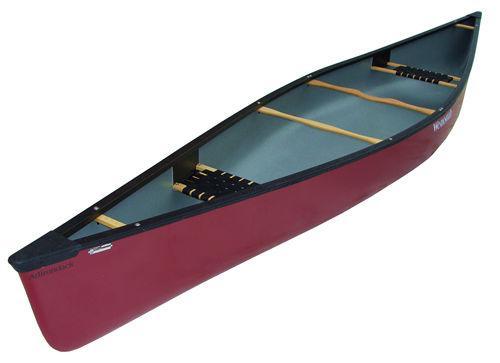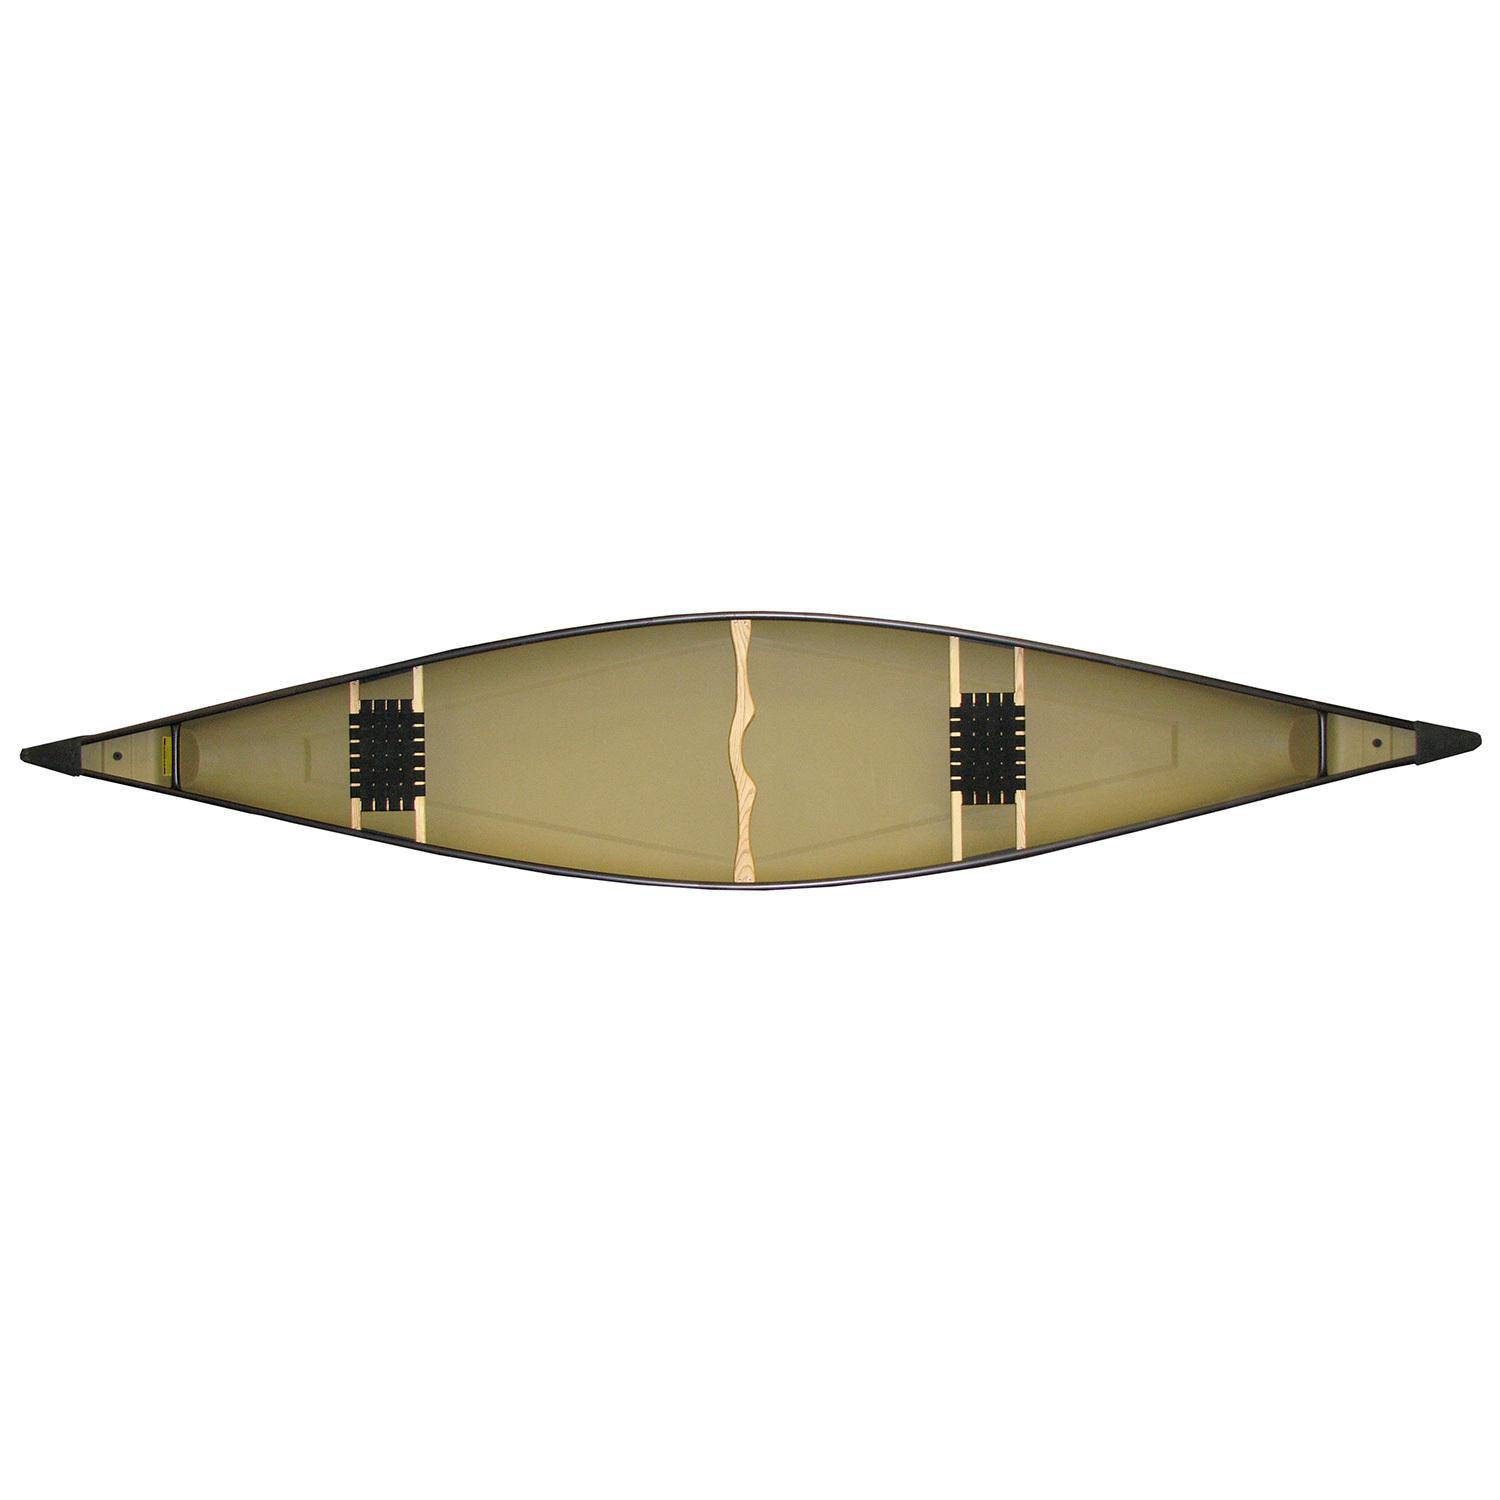The first image is the image on the left, the second image is the image on the right. Evaluate the accuracy of this statement regarding the images: "Each image features a top-viewed canoe above a side view of a canoe.". Is it true? Answer yes or no. No. The first image is the image on the left, the second image is the image on the right. Assess this claim about the two images: "There is a yellow canoe.". Correct or not? Answer yes or no. No. 